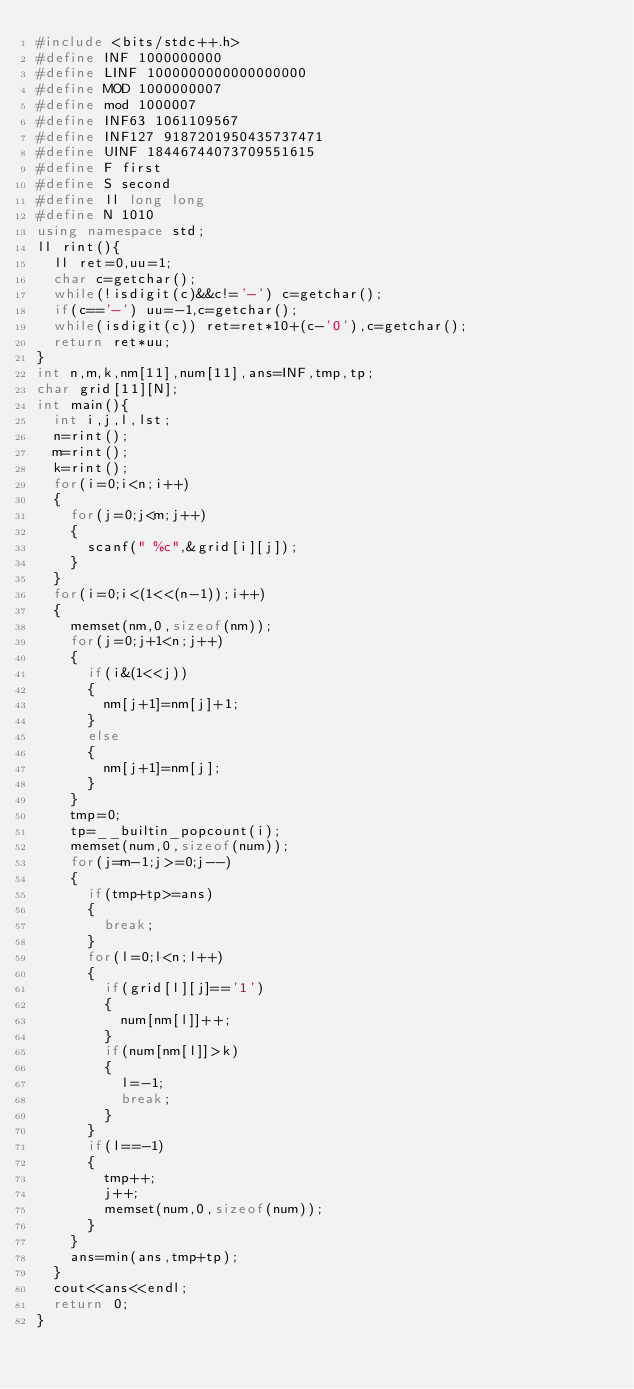Convert code to text. <code><loc_0><loc_0><loc_500><loc_500><_C++_>#include <bits/stdc++.h>
#define INF 1000000000
#define LINF 1000000000000000000
#define MOD 1000000007
#define mod 1000007
#define INF63 1061109567
#define INF127 9187201950435737471
#define UINF 18446744073709551615
#define F first
#define S second
#define ll long long
#define N 1010
using namespace std;
ll rint(){
	ll ret=0,uu=1;
	char c=getchar();
	while(!isdigit(c)&&c!='-') c=getchar();
	if(c=='-') uu=-1,c=getchar();
	while(isdigit(c)) ret=ret*10+(c-'0'),c=getchar();
	return ret*uu;
}
int n,m,k,nm[11],num[11],ans=INF,tmp,tp;
char grid[11][N];
int main(){
	int i,j,l,lst;
	n=rint();
	m=rint();
	k=rint();
	for(i=0;i<n;i++)
	{
		for(j=0;j<m;j++)
		{
			scanf(" %c",&grid[i][j]);
		}
	}
	for(i=0;i<(1<<(n-1));i++)
	{
		memset(nm,0,sizeof(nm));
		for(j=0;j+1<n;j++)
		{
			if(i&(1<<j))
			{
				nm[j+1]=nm[j]+1;
			}
			else
			{
				nm[j+1]=nm[j];
			}
		}
		tmp=0;
		tp=__builtin_popcount(i);
		memset(num,0,sizeof(num));
		for(j=m-1;j>=0;j--)
		{
			if(tmp+tp>=ans)
			{
				break;
			}
			for(l=0;l<n;l++)
			{
				if(grid[l][j]=='1')
				{
					num[nm[l]]++;
				}
				if(num[nm[l]]>k)
				{
					l=-1;
					break;
				}
			}
			if(l==-1)
			{
				tmp++;
				j++;
				memset(num,0,sizeof(num));
			}
		}
		ans=min(ans,tmp+tp);
	}
	cout<<ans<<endl;
	return 0;
}</code> 